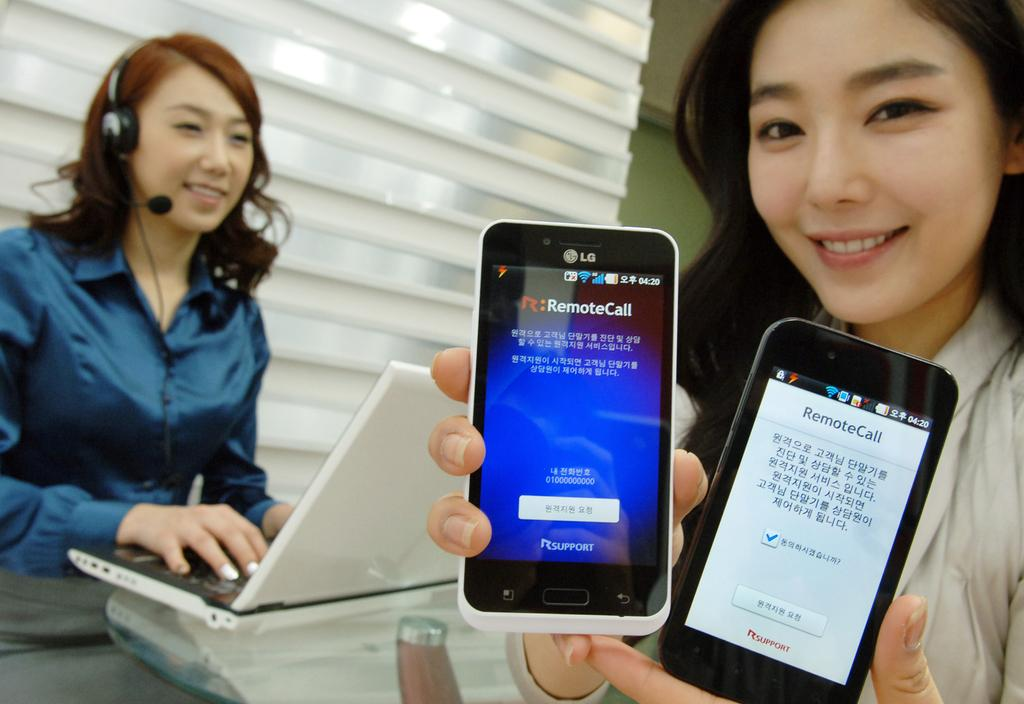<image>
Create a compact narrative representing the image presented. A woman holding up two phones that both say RemoteCall. 